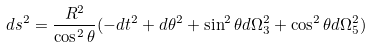Convert formula to latex. <formula><loc_0><loc_0><loc_500><loc_500>d s ^ { 2 } = \frac { R ^ { 2 } } { \cos ^ { 2 } \theta } ( - d t ^ { 2 } + d \theta ^ { 2 } + \sin ^ { 2 } \theta d \Omega _ { 3 } ^ { 2 } + \cos ^ { 2 } \theta d \Omega _ { 5 } ^ { 2 } )</formula> 